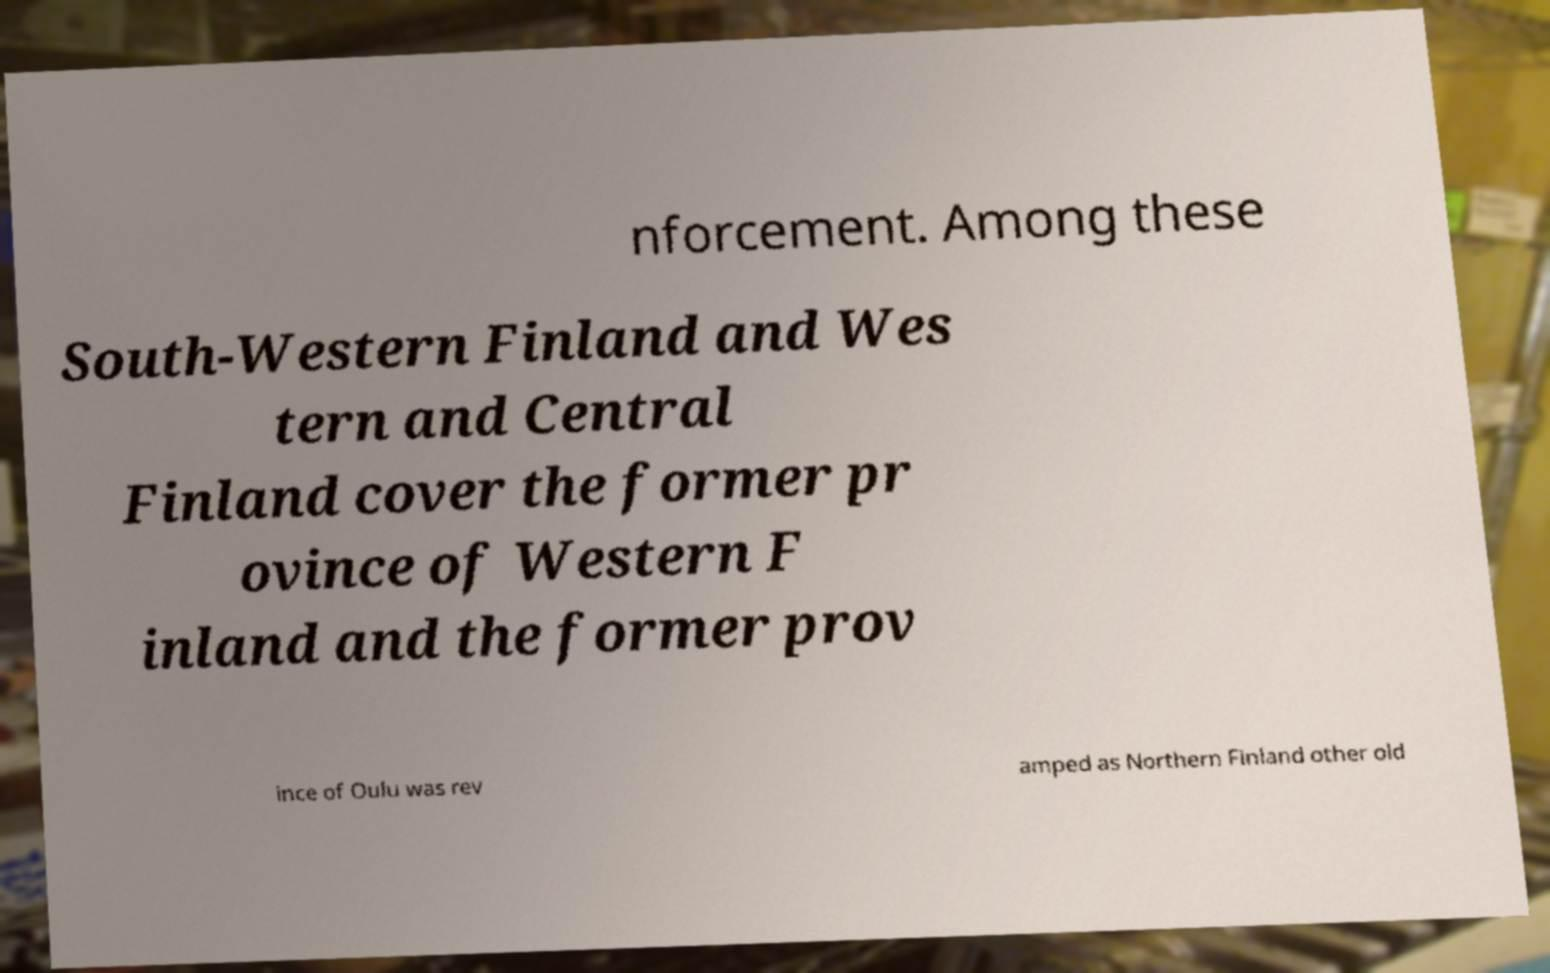There's text embedded in this image that I need extracted. Can you transcribe it verbatim? nforcement. Among these South-Western Finland and Wes tern and Central Finland cover the former pr ovince of Western F inland and the former prov ince of Oulu was rev amped as Northern Finland other old 